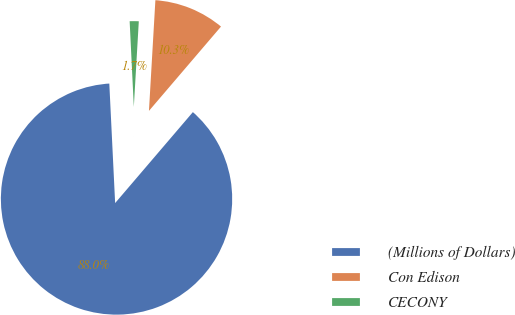Convert chart to OTSL. <chart><loc_0><loc_0><loc_500><loc_500><pie_chart><fcel>(Millions of Dollars)<fcel>Con Edison<fcel>CECONY<nl><fcel>87.97%<fcel>10.33%<fcel>1.7%<nl></chart> 